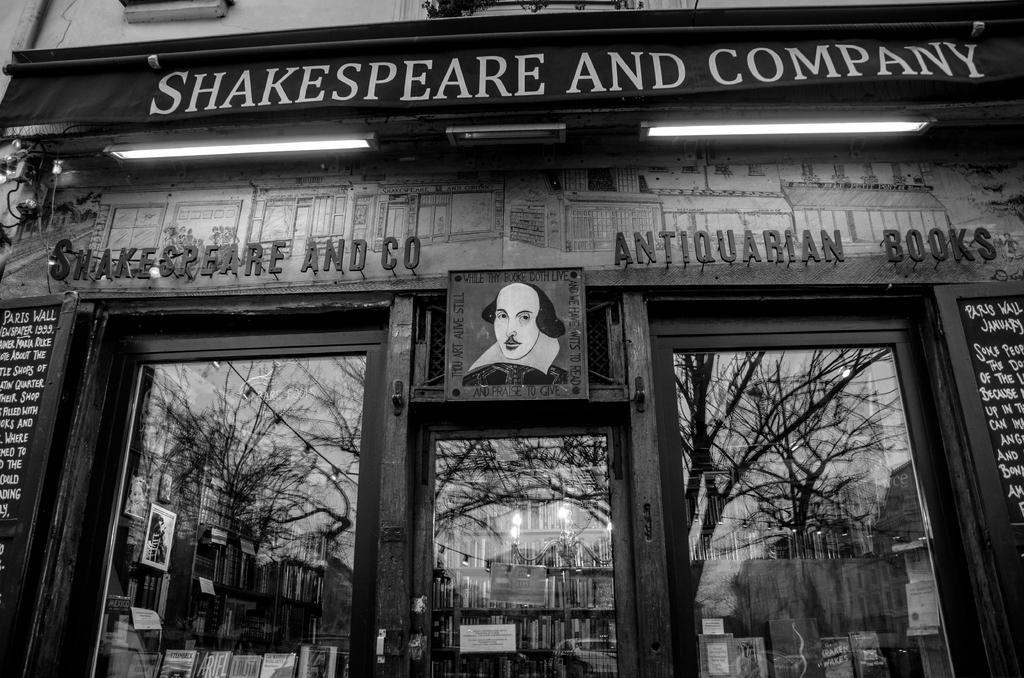What type of door is visible in the image? There is a glass door in the image. To which establishment does the glass door belong? The glass door belongs to a shop. What is located above the glass door? There is a naming board above the glass door. What is written on the naming board? "Shakespeare and company" is written on the naming board. What type of lipstick is the judge wearing in the image? There is no judge or lipstick present in the image; it features a glass door, a shop, and a naming board. 